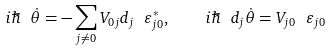Convert formula to latex. <formula><loc_0><loc_0><loc_500><loc_500>i \hbar { \ } \dot { \theta } = - \sum _ { j \ne 0 } V _ { 0 j } d _ { j } \ \varepsilon _ { j 0 } ^ { * } , \quad i \hbar { \ } d _ { j } \dot { \theta } = V _ { j 0 } \ \varepsilon _ { j 0 }</formula> 